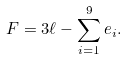Convert formula to latex. <formula><loc_0><loc_0><loc_500><loc_500>F = 3 \ell - \sum _ { i = 1 } ^ { 9 } e _ { i } .</formula> 